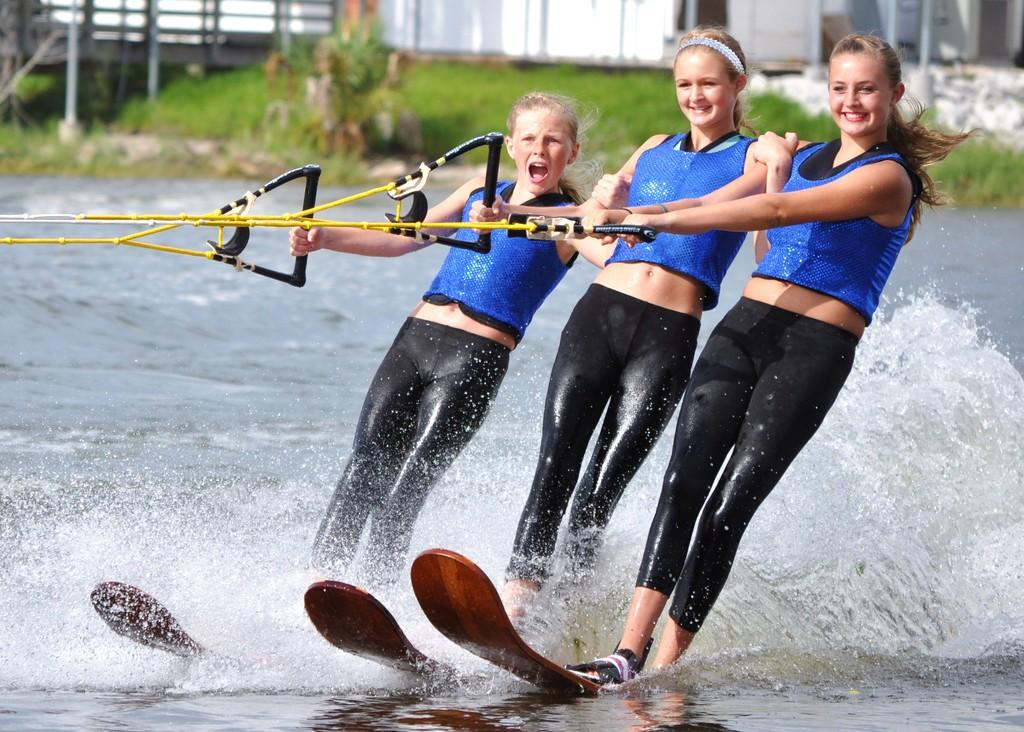How many people are in the image? There are three people in the image. What are the people doing in the image? The people are water-skiing on water. What are the people holding in the image? The people are holding objects, which are likely water-skiing equipment. What can be seen in the background of the image? There is grass in the background of the image. Are there any cacti visible in the image? No, there are no cacti present in the image. Can you tell me how fast the people are swimming in the image? The people are not swimming; they are water-skiing on water. 